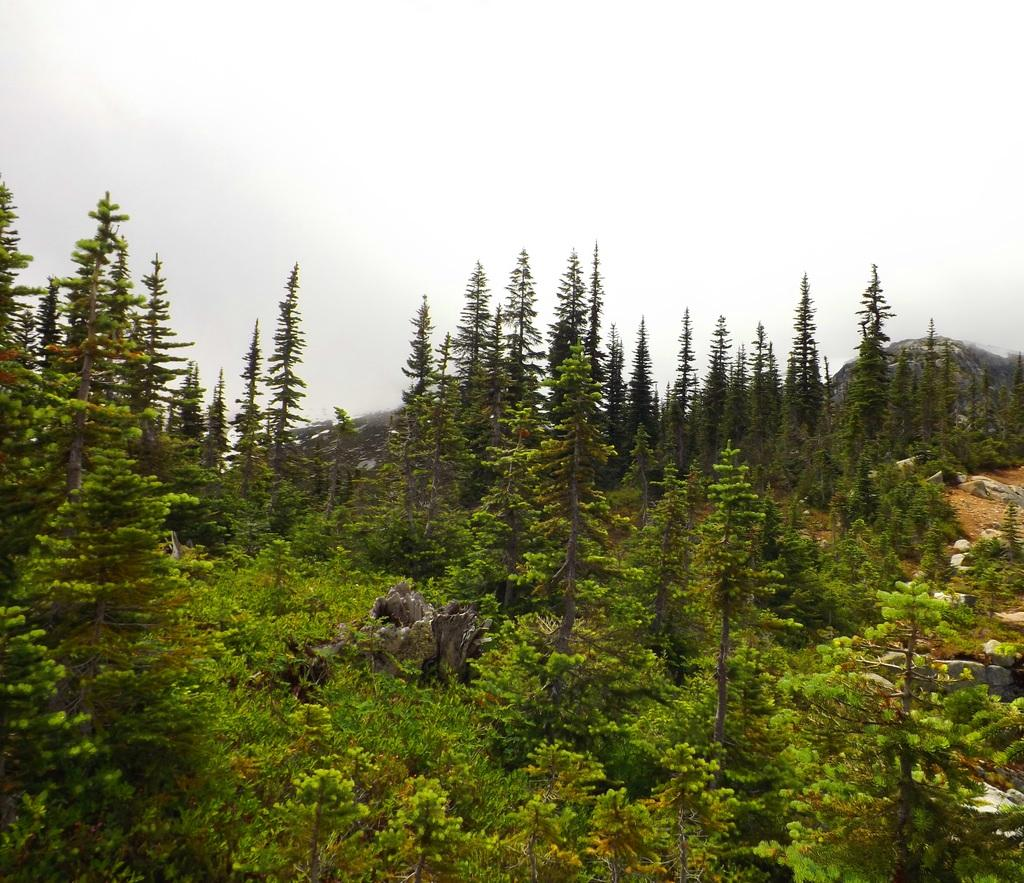What type of vegetation can be seen in the image? There are trees and plants in the image. What natural element is present in the image? There is a rock in the image. Can you describe the main subject of the image? The image appears to depict a forest. What part of a tree is visible in the image? There is a tree trunk in the image. How many beds can be seen in the image? There are no beds present in the image. What type of monkey is climbing the tree in the image? There is no monkey present in the image; it depicts a forest with trees and plants. 